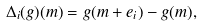<formula> <loc_0><loc_0><loc_500><loc_500>\Delta _ { i } ( g ) ( m ) = g ( m + e _ { i } ) - g ( m ) ,</formula> 